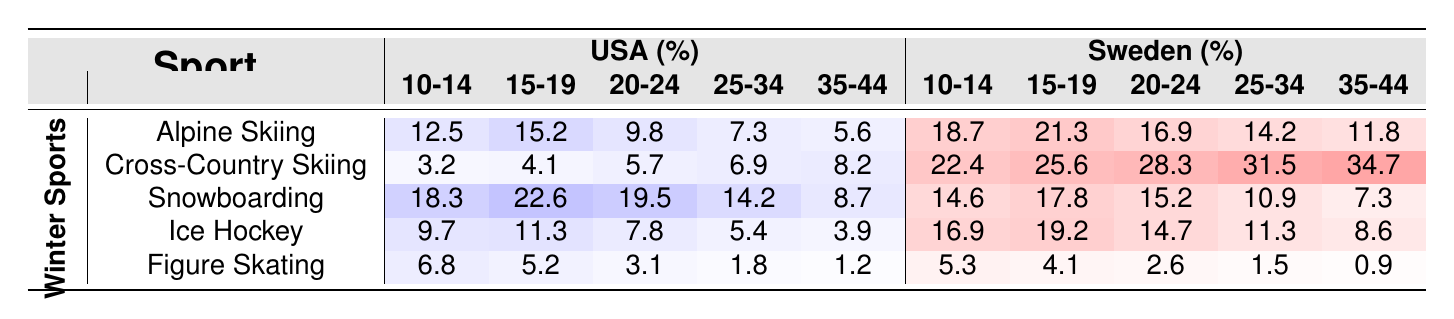What is the participation rate in Alpine Skiing for 10-14 year olds in the USA? The table shows that the participation rate for USA in Alpine Skiing for 10-14 year olds is 12.5%.
Answer: 12.5% Which age group in Sweden has the highest participation rate in Cross-Country Skiing? Looking at the row for Sweden under Cross-Country Skiing, the highest percentage is in the 35-44 age group at 34.7%.
Answer: 35-44 What is the difference in participation rates for Figure Skating between 25-34 year olds in the USA and Sweden? In the USA, it's 1.8%, and in Sweden, it's 1.5%. The difference is 1.8% - 1.5% = 0.3%.
Answer: 0.3% Do more teenagers (15-19 years) in the USA participate in Snowboarding than in Ice Hockey? The participation rate for Snowboarding in the USA for 15-19 years is 22.6% and for Ice Hockey, it's 11.3%. Since 22.6% is greater than 11.3%, the answer is yes.
Answer: Yes What is the average participation rate in Snowboarding for the 10-14 age group across both countries? The USA has 18.3% and Sweden has 14.6% for Snowboarding in the 10-14 age group. The average is (18.3 + 14.6) / 2 = 16.45%.
Answer: 16.45% In which sport do 20-24 year olds in Sweden have the lowest participation rate? Examining the row for Sweden, Figure Skating has the lowest rate of 2.6% among the sports for the 20-24 age group.
Answer: Figure Skating If we total the participation rates for Cross-Country Skiing in all age groups for Sweden, what is the total? Summing the participation rates for all age groups in Sweden: 22.4 + 25.6 + 28.3 + 31.5 + 34.7 = 142.5%.
Answer: 142.5% Which sport shows a decline in participation from the 15-19 to the 25-34 age group in the USA? The participation rates for Ice Hockey decrease from 11.3% (15-19) to 5.4% (25-34). This indicates a decline.
Answer: Ice Hockey Are there any sports in which participation rates for 35-44 year olds in Sweden are higher than those in the USA? Yes, examining the 35-44 year group, in Ice Hockey (8.6% vs. 3.9%), Cross-Country Skiing (34.7% vs. 8.2%), and Alpine Skiing (11.8% vs. 5.6%), all show higher rates in Sweden.
Answer: Yes What percentage of 15-19 year olds in the USA participate in Figure Skating compared to Cross-Country Skiing? In the USA, Figure Skating has a participation rate of 5.2% and Cross-Country Skiing has 4.1%. 5.2% is greater than 4.1%.
Answer: 5.2% vs. 4.1%, Figure Skating is higher 